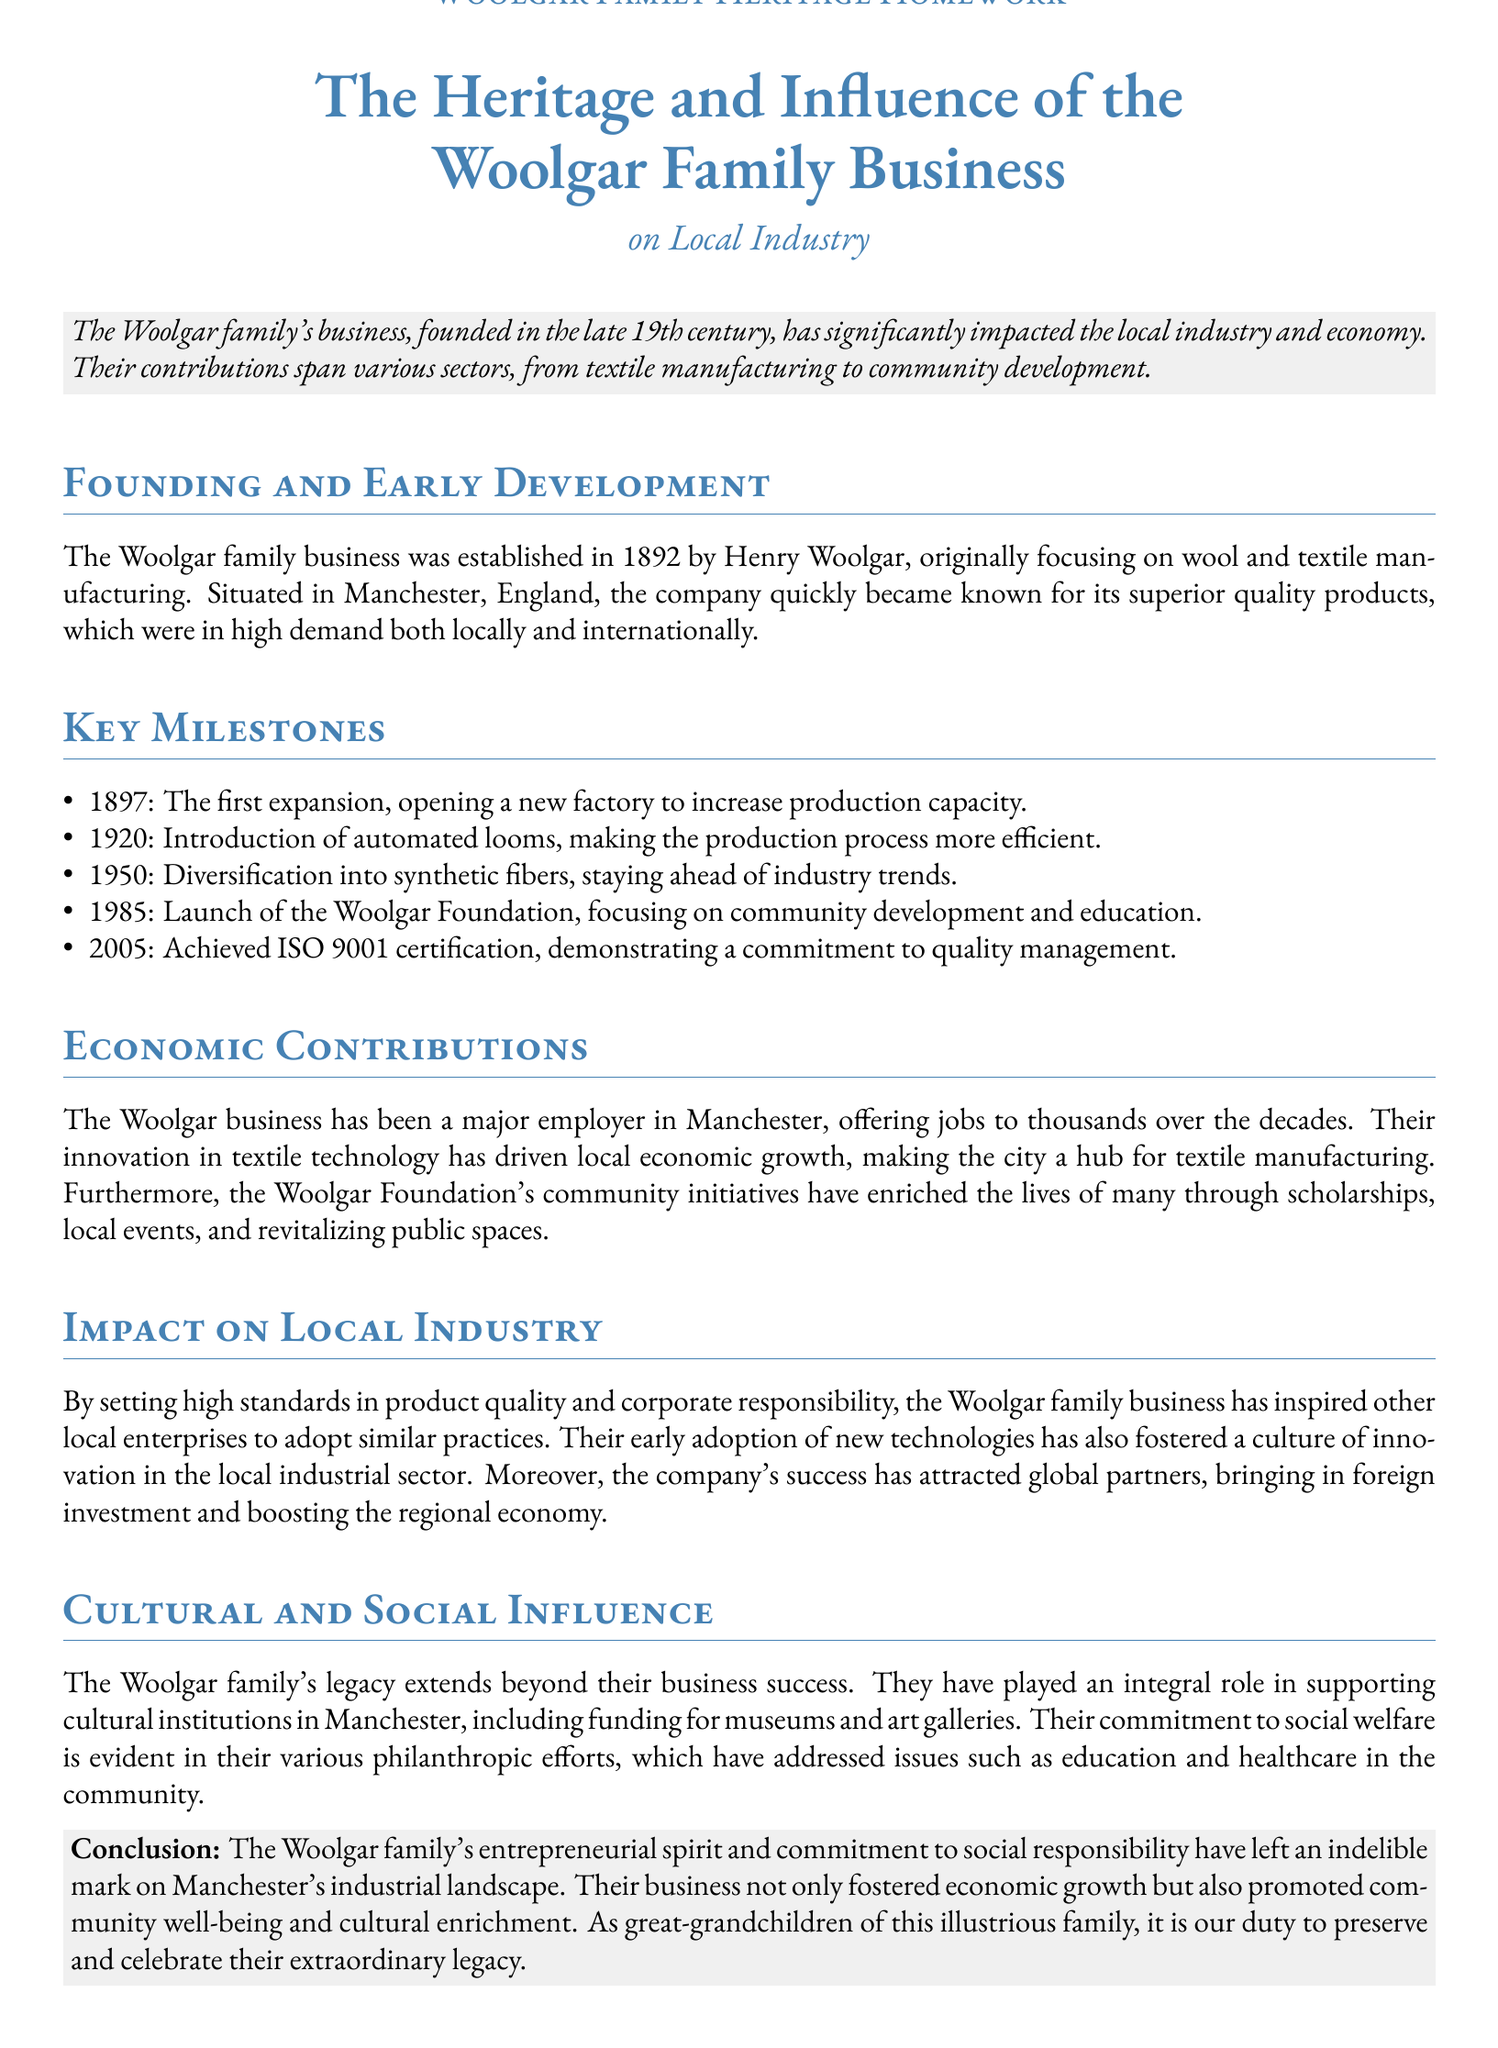What year was the Woolgar family business founded? The founding year is explicitly mentioned in the document, which is 1892.
Answer: 1892 Who established the Woolgar family business? The document states that Henry Woolgar founded the business.
Answer: Henry Woolgar What key technological advancement was introduced in 1920? The document indicates that automated looms were introduced, enhancing production efficiency.
Answer: Automated looms What organization was launched in 1985? The Woolgar Foundation was specifically mentioned as launched in 1985.
Answer: Woolgar Foundation How did the Woolgar family business impact local employment? The text specifies that it has offered jobs to thousands over the decades, indicating significant employment impact.
Answer: Thousands What was the significance of achieving ISO 9001 certification in 2005? The achievement of ISO 9001 certification is highlighted as a demonstration of a commitment to quality management.
Answer: Quality management In what way did the Woolgar family influence local industries? The document mentions they inspired other local enterprises to adopt high standards in product quality and corporate responsibility.
Answer: High standards What cultural contribution has the Woolgar family made to Manchester? The document states their integral role in supporting cultural institutions by funding museums and art galleries.
Answer: Museums and art galleries What main focus did the Woolgar Foundation have? The document highlights the focus on community development and education as the main mission of the Woolgar Foundation.
Answer: Community development and education 